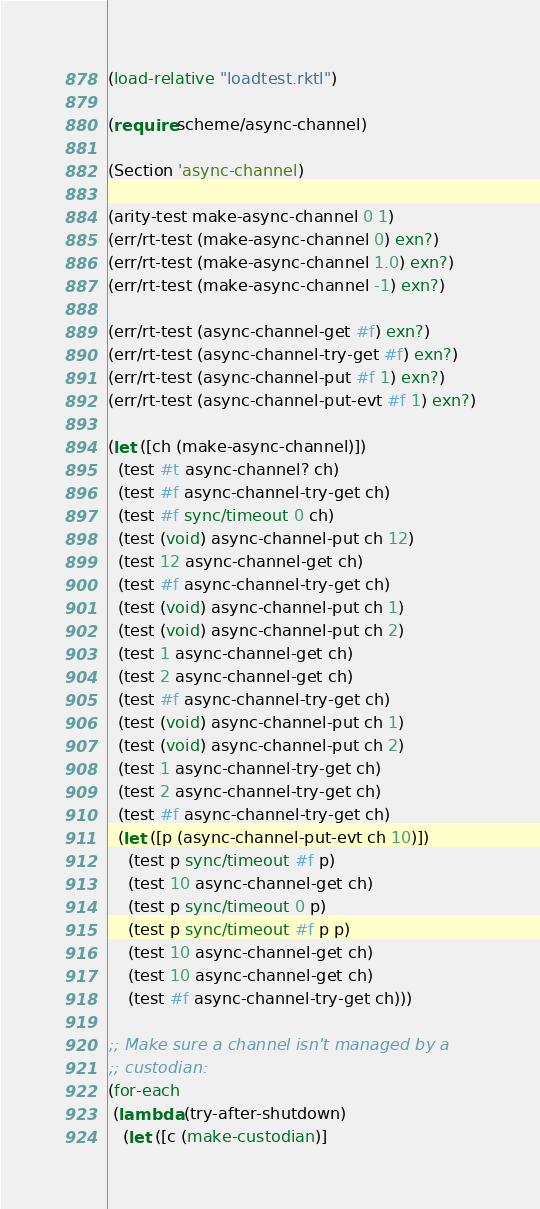<code> <loc_0><loc_0><loc_500><loc_500><_Racket_>

(load-relative "loadtest.rktl")

(require scheme/async-channel)

(Section 'async-channel)

(arity-test make-async-channel 0 1)
(err/rt-test (make-async-channel 0) exn?)
(err/rt-test (make-async-channel 1.0) exn?)
(err/rt-test (make-async-channel -1) exn?)

(err/rt-test (async-channel-get #f) exn?)
(err/rt-test (async-channel-try-get #f) exn?)
(err/rt-test (async-channel-put #f 1) exn?)
(err/rt-test (async-channel-put-evt #f 1) exn?)

(let ([ch (make-async-channel)])
  (test #t async-channel? ch)
  (test #f async-channel-try-get ch)
  (test #f sync/timeout 0 ch)
  (test (void) async-channel-put ch 12)
  (test 12 async-channel-get ch)
  (test #f async-channel-try-get ch)
  (test (void) async-channel-put ch 1)
  (test (void) async-channel-put ch 2)
  (test 1 async-channel-get ch)
  (test 2 async-channel-get ch)
  (test #f async-channel-try-get ch)
  (test (void) async-channel-put ch 1)
  (test (void) async-channel-put ch 2)
  (test 1 async-channel-try-get ch)
  (test 2 async-channel-try-get ch)
  (test #f async-channel-try-get ch)
  (let ([p (async-channel-put-evt ch 10)])
    (test p sync/timeout #f p)
    (test 10 async-channel-get ch)
    (test p sync/timeout 0 p)
    (test p sync/timeout #f p p)
    (test 10 async-channel-get ch)
    (test 10 async-channel-get ch)
    (test #f async-channel-try-get ch)))

;; Make sure a channel isn't managed by a
;; custodian:
(for-each
 (lambda (try-after-shutdown)
   (let ([c (make-custodian)]</code> 